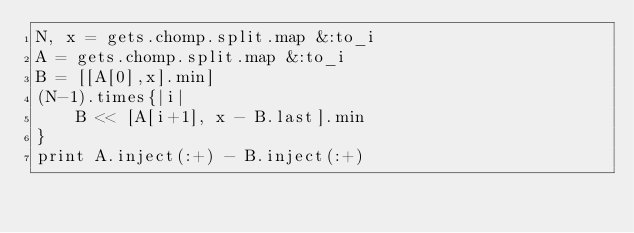<code> <loc_0><loc_0><loc_500><loc_500><_Ruby_>N, x = gets.chomp.split.map &:to_i
A = gets.chomp.split.map &:to_i
B = [[A[0],x].min]
(N-1).times{|i|
	B << [A[i+1], x - B.last].min
}
print A.inject(:+) - B.inject(:+)</code> 